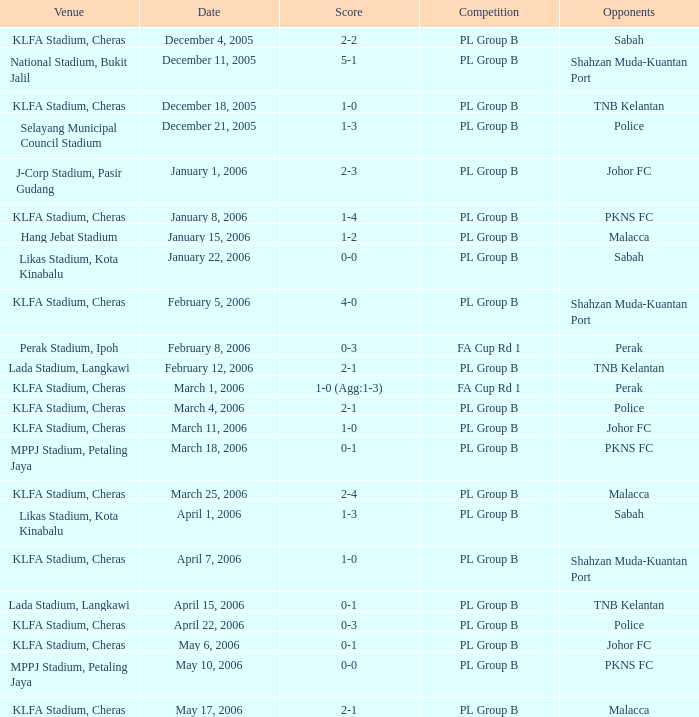Which Venue has a Competition of pl group b, and a Score of 2-2? KLFA Stadium, Cheras. 